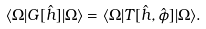<formula> <loc_0><loc_0><loc_500><loc_500>\langle \Omega | G [ \hat { h } ] | \Omega \rangle = \langle \Omega | T [ \hat { h } , \hat { \phi } ] | \Omega \rangle .</formula> 